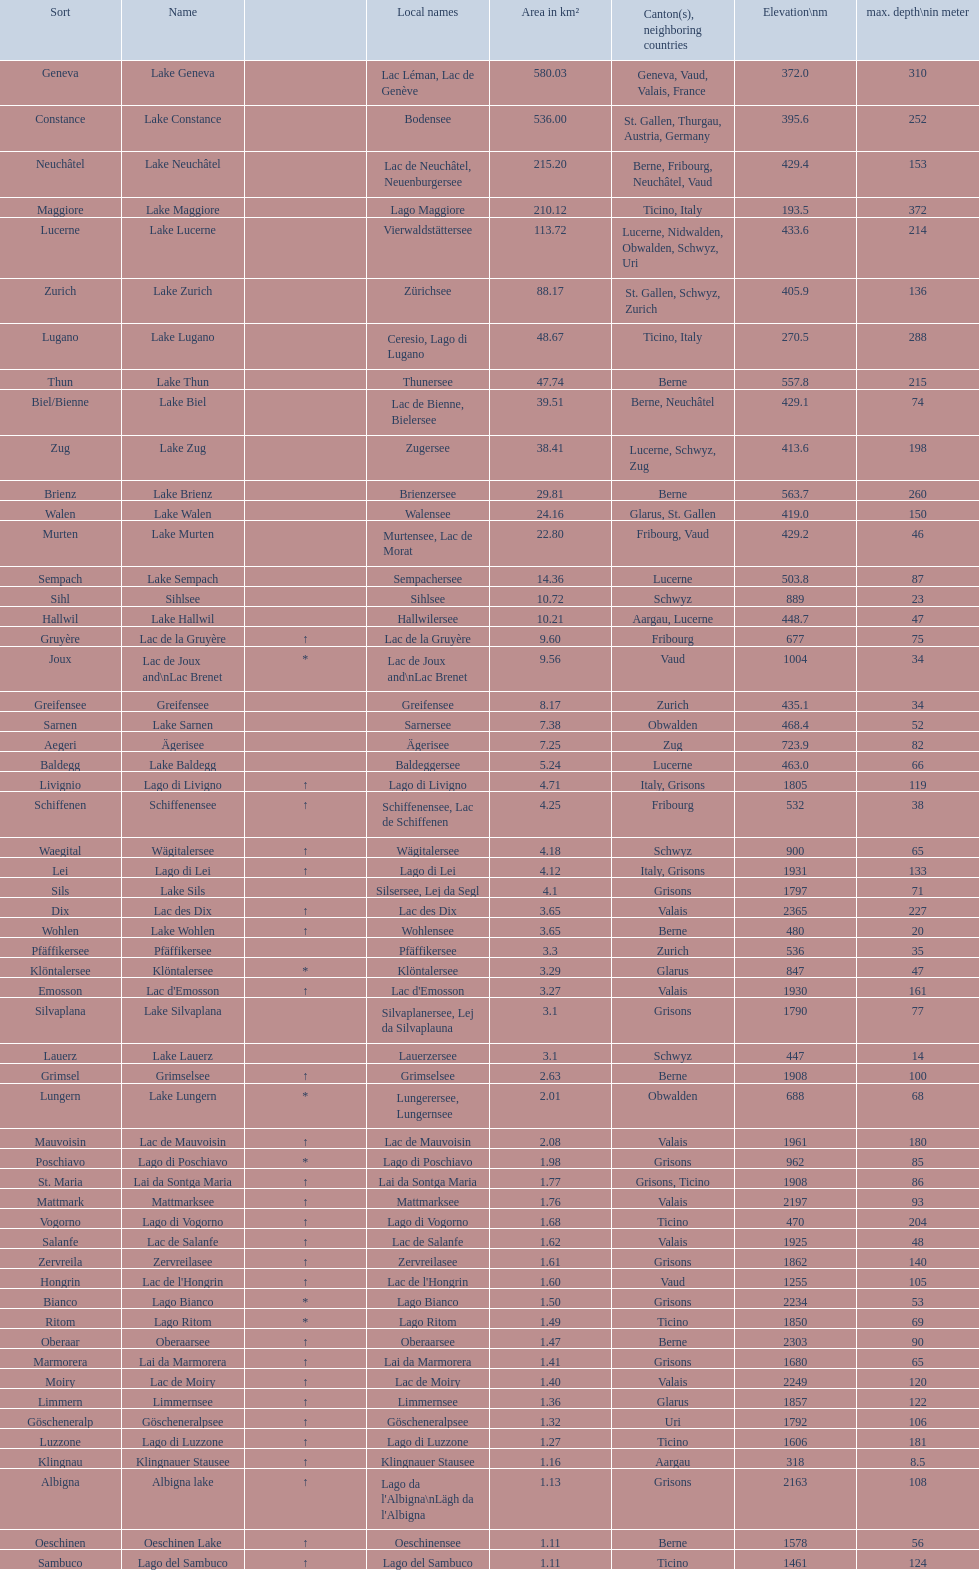Which lake has the largest elevation? Lac des Dix. 